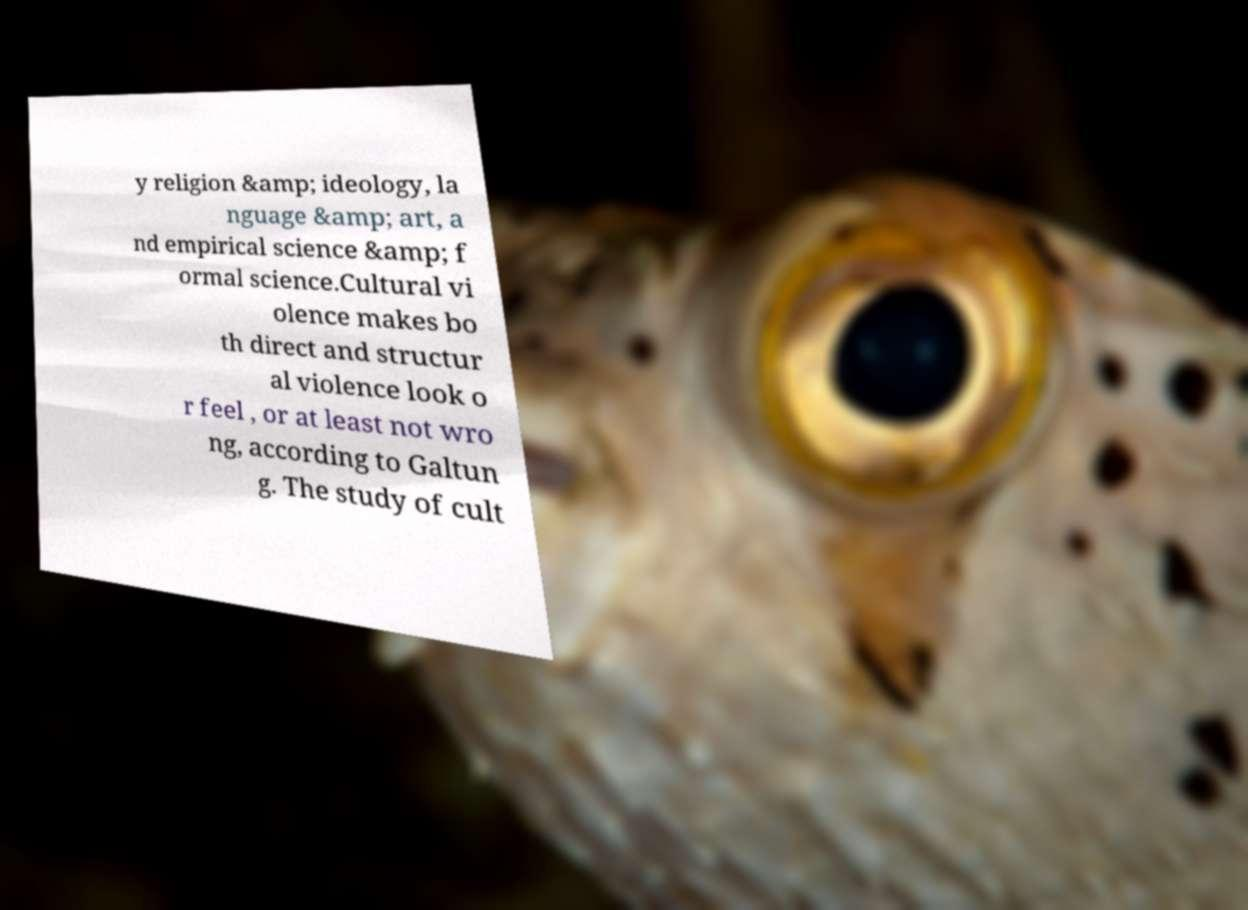Please read and relay the text visible in this image. What does it say? y religion &amp; ideology, la nguage &amp; art, a nd empirical science &amp; f ormal science.Cultural vi olence makes bo th direct and structur al violence look o r feel , or at least not wro ng, according to Galtun g. The study of cult 